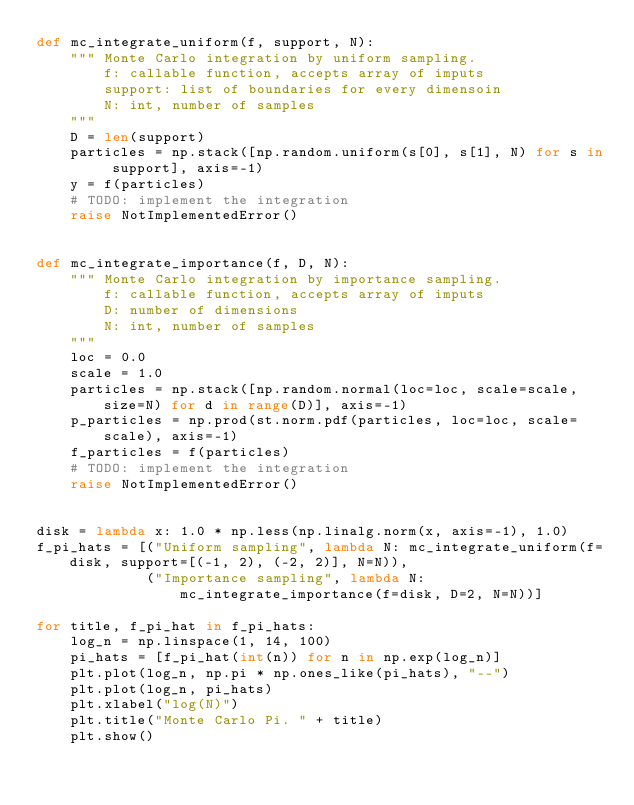<code> <loc_0><loc_0><loc_500><loc_500><_Python_>def mc_integrate_uniform(f, support, N):
    """ Monte Carlo integration by uniform sampling.
        f: callable function, accepts array of imputs
        support: list of boundaries for every dimensoin
        N: int, number of samples
    """
    D = len(support)
    particles = np.stack([np.random.uniform(s[0], s[1], N) for s in support], axis=-1)
    y = f(particles)
    # TODO: implement the integration
    raise NotImplementedError() 


def mc_integrate_importance(f, D, N):
    """ Monte Carlo integration by importance sampling.
        f: callable function, accepts array of imputs
        D: number of dimensions
        N: int, number of samples
    """
    loc = 0.0
    scale = 1.0
    particles = np.stack([np.random.normal(loc=loc, scale=scale, size=N) for d in range(D)], axis=-1)
    p_particles = np.prod(st.norm.pdf(particles, loc=loc, scale=scale), axis=-1)
    f_particles = f(particles)
    # TODO: implement the integration
    raise NotImplementedError() 


disk = lambda x: 1.0 * np.less(np.linalg.norm(x, axis=-1), 1.0)
f_pi_hats = [("Uniform sampling", lambda N: mc_integrate_uniform(f=disk, support=[(-1, 2), (-2, 2)], N=N)), 
             ("Importance sampling", lambda N: mc_integrate_importance(f=disk, D=2, N=N))]

for title, f_pi_hat in f_pi_hats:
    log_n = np.linspace(1, 14, 100)
    pi_hats = [f_pi_hat(int(n)) for n in np.exp(log_n)]
    plt.plot(log_n, np.pi * np.ones_like(pi_hats), "--")
    plt.plot(log_n, pi_hats)
    plt.xlabel("log(N)")
    plt.title("Monte Carlo Pi. " + title)
    plt.show()
</code> 